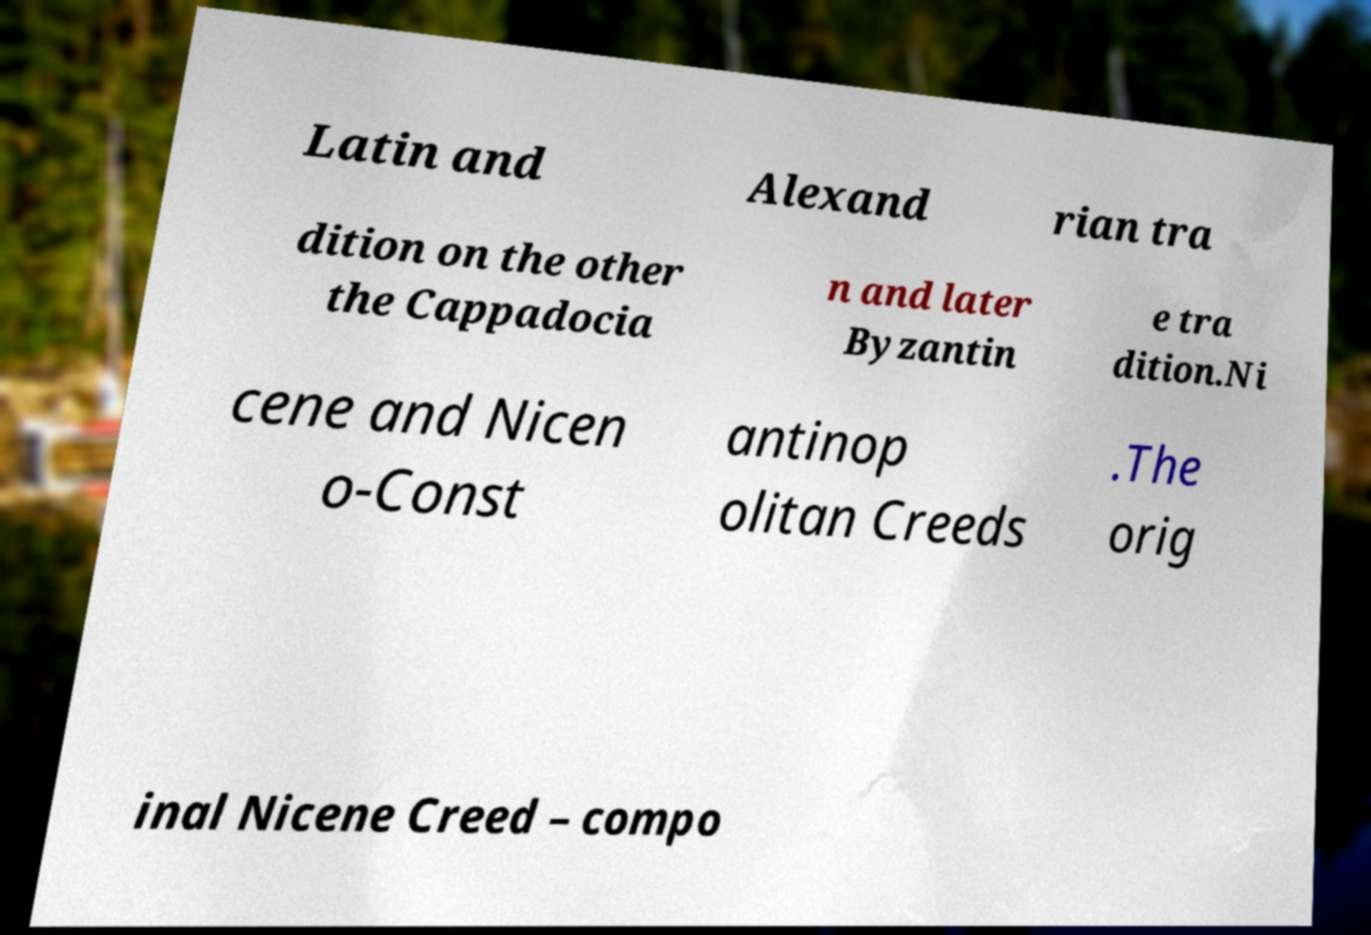I need the written content from this picture converted into text. Can you do that? Latin and Alexand rian tra dition on the other the Cappadocia n and later Byzantin e tra dition.Ni cene and Nicen o-Const antinop olitan Creeds .The orig inal Nicene Creed – compo 